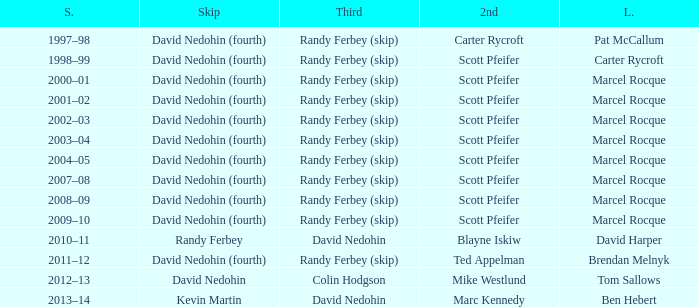Which Third has a Second of scott pfeifer? Randy Ferbey (skip), Randy Ferbey (skip), Randy Ferbey (skip), Randy Ferbey (skip), Randy Ferbey (skip), Randy Ferbey (skip), Randy Ferbey (skip), Randy Ferbey (skip), Randy Ferbey (skip). 